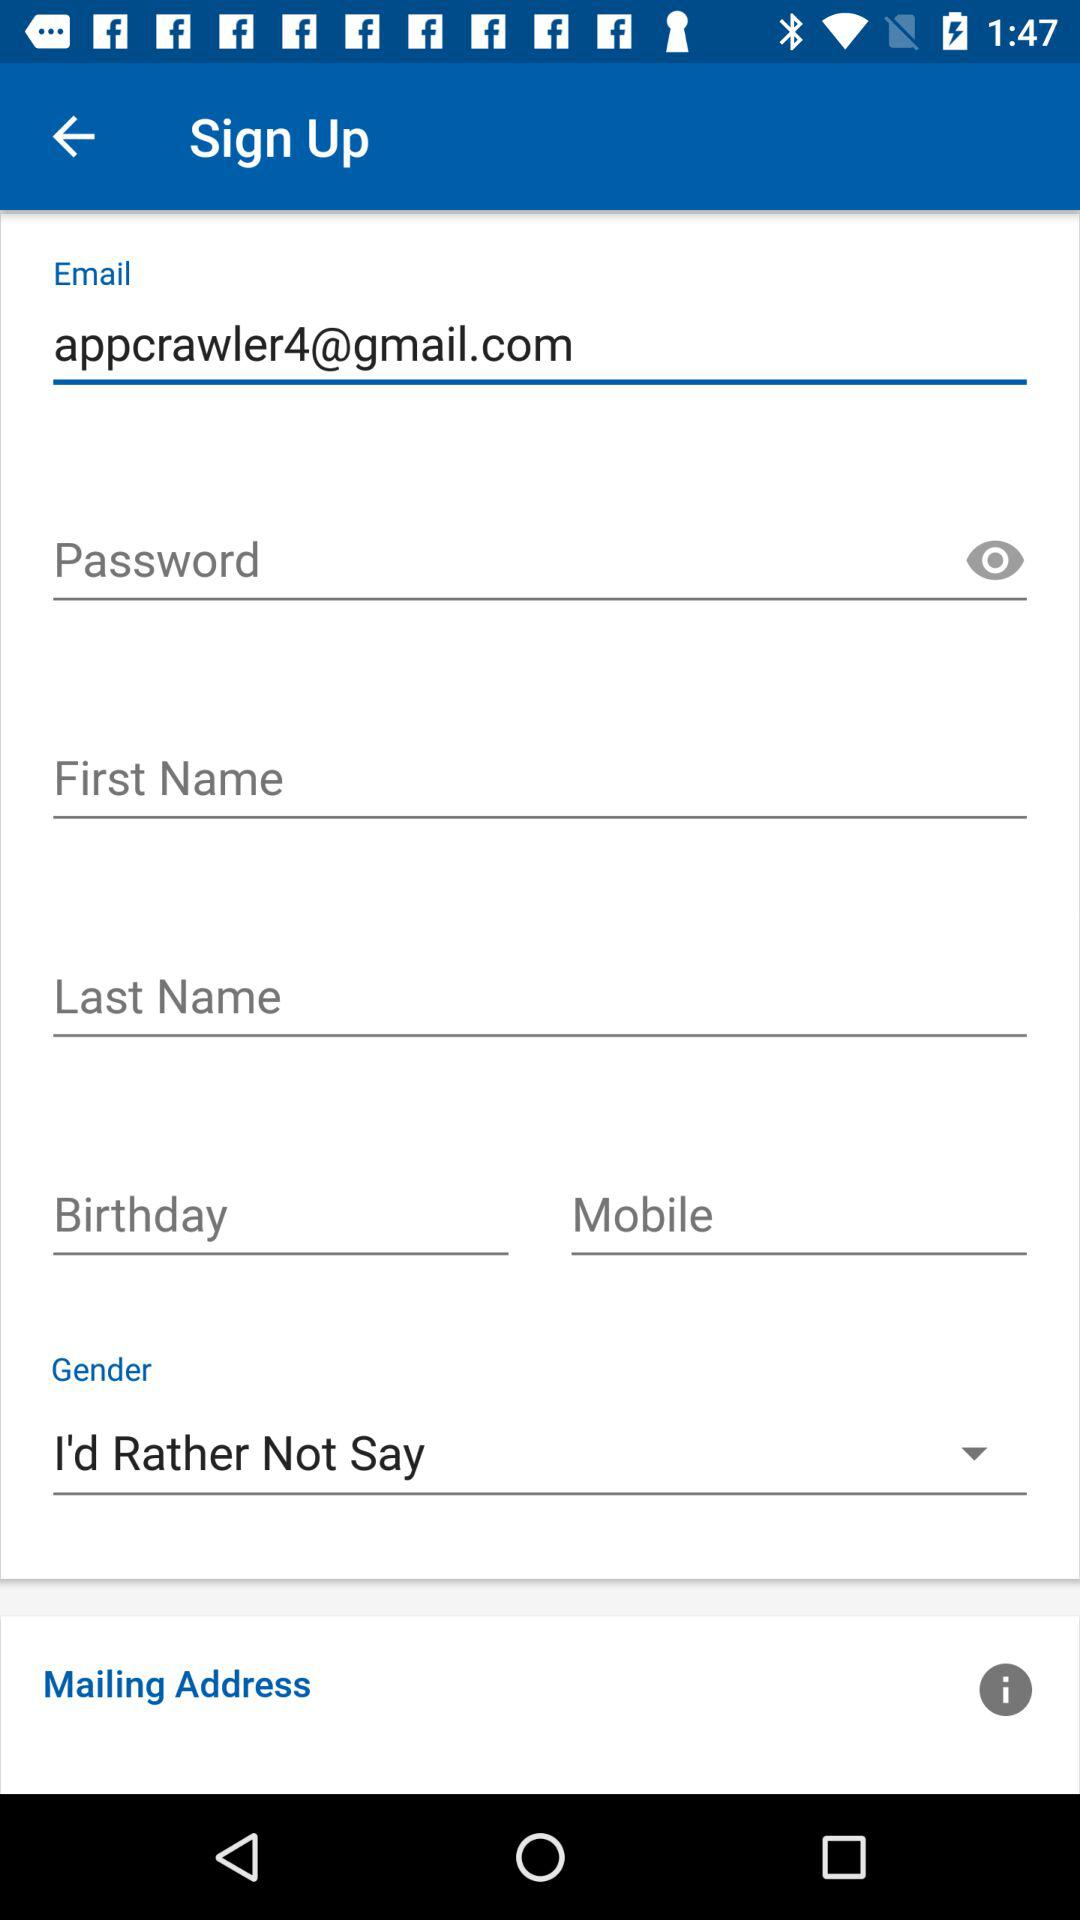What is the selected gender? The selected gender is "I'd Rather Not Say". 